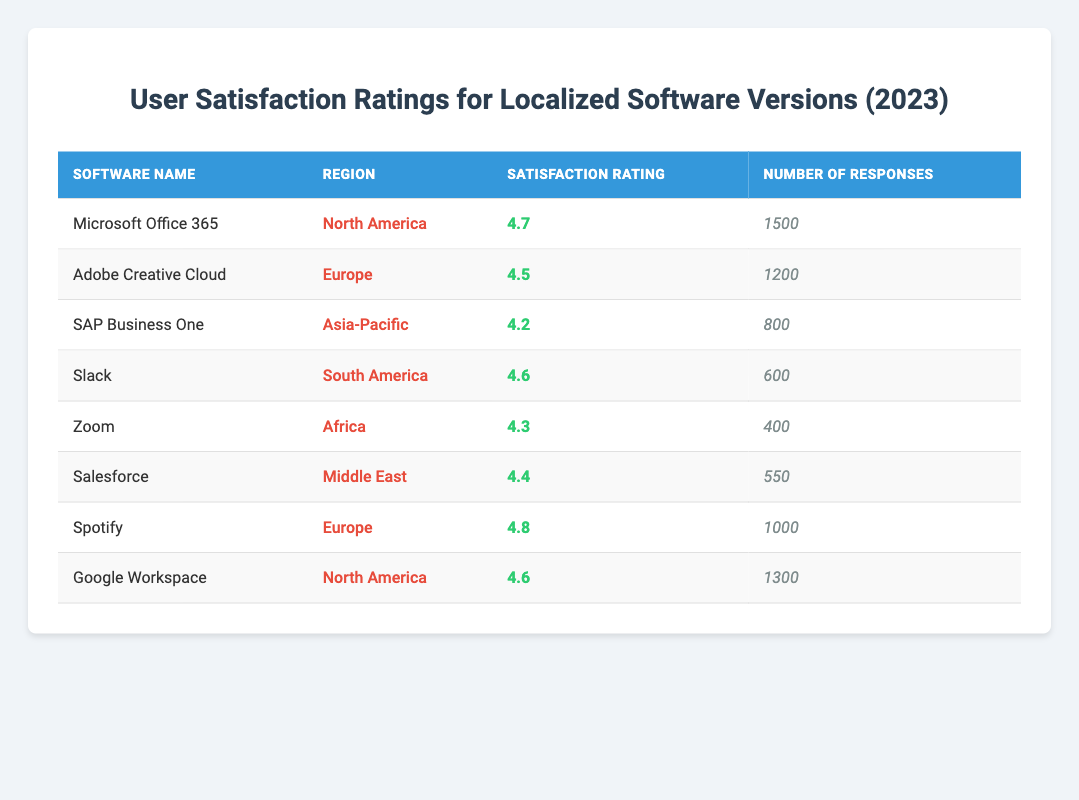What is the satisfaction rating for Microsoft Office 365 in North America? The table indicates that the satisfaction rating for Microsoft Office 365 in North America is 4.7.
Answer: 4.7 Which software has the highest satisfaction rating in Europe? By examining the ratings in Europe, Spotify has a rating of 4.8, which is higher than Adobe Creative Cloud's rating of 4.5.
Answer: Spotify How many total responses were collected for software in North America? The total responses for software in North America are from Microsoft Office 365 (1500) and Google Workspace (1300). Adding these together gives 1500 + 1300 = 2800.
Answer: 2800 Is the satisfaction rating for SAP Business One in Asia-Pacific above 4.5? The rating for SAP Business One is 4.2, which is below 4.5, so the statement is false.
Answer: No What is the average satisfaction rating for all software listed in the table? To find the average, sum the satisfaction ratings: 4.7 + 4.5 + 4.2 + 4.6 + 4.3 + 4.4 + 4.8 + 4.6 = 36.1. There are 8 ratings, so the average is 36.1 / 8 = 4.5125.
Answer: 4.51 In which region did Salesforce receive a satisfaction rating of 4.4? The table shows that Salesforce received a satisfaction rating of 4.4 in the Middle East region.
Answer: Middle East Comparing Zoom and Slack, which one had more responses? Zoom received 400 responses, while Slack received 600 responses. Since 600 (Slack) is greater than 400 (Zoom), Slack had more responses.
Answer: Slack What is the difference in satisfaction ratings between Spotify and Zoom? Spotify has a satisfaction rating of 4.8, while Zoom has a rating of 4.3. The difference is calculated as 4.8 - 4.3 = 0.5.
Answer: 0.5 